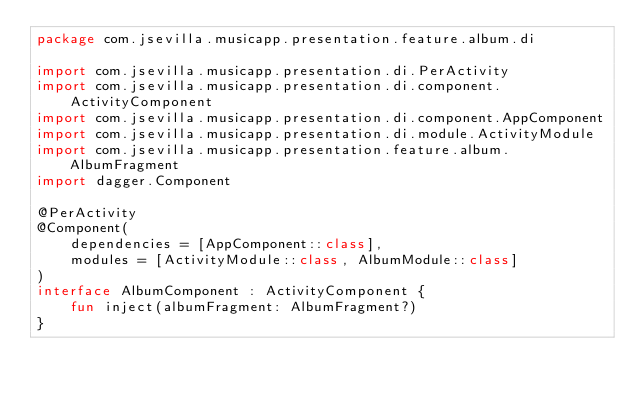<code> <loc_0><loc_0><loc_500><loc_500><_Kotlin_>package com.jsevilla.musicapp.presentation.feature.album.di

import com.jsevilla.musicapp.presentation.di.PerActivity
import com.jsevilla.musicapp.presentation.di.component.ActivityComponent
import com.jsevilla.musicapp.presentation.di.component.AppComponent
import com.jsevilla.musicapp.presentation.di.module.ActivityModule
import com.jsevilla.musicapp.presentation.feature.album.AlbumFragment
import dagger.Component

@PerActivity
@Component(
    dependencies = [AppComponent::class],
    modules = [ActivityModule::class, AlbumModule::class]
)
interface AlbumComponent : ActivityComponent {
    fun inject(albumFragment: AlbumFragment?)
}
</code> 